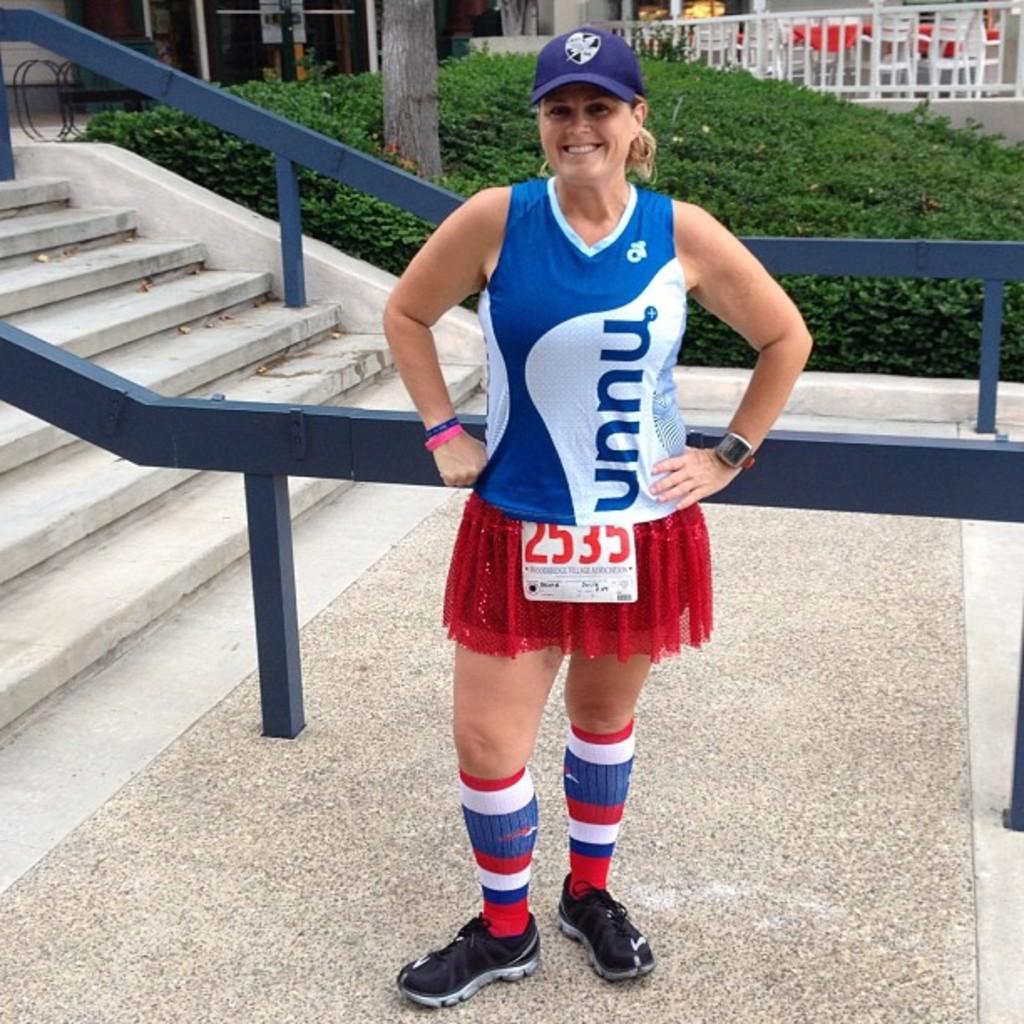<image>
Describe the image concisely. a woman wearing a UNNU jersey smiles by some stairs 